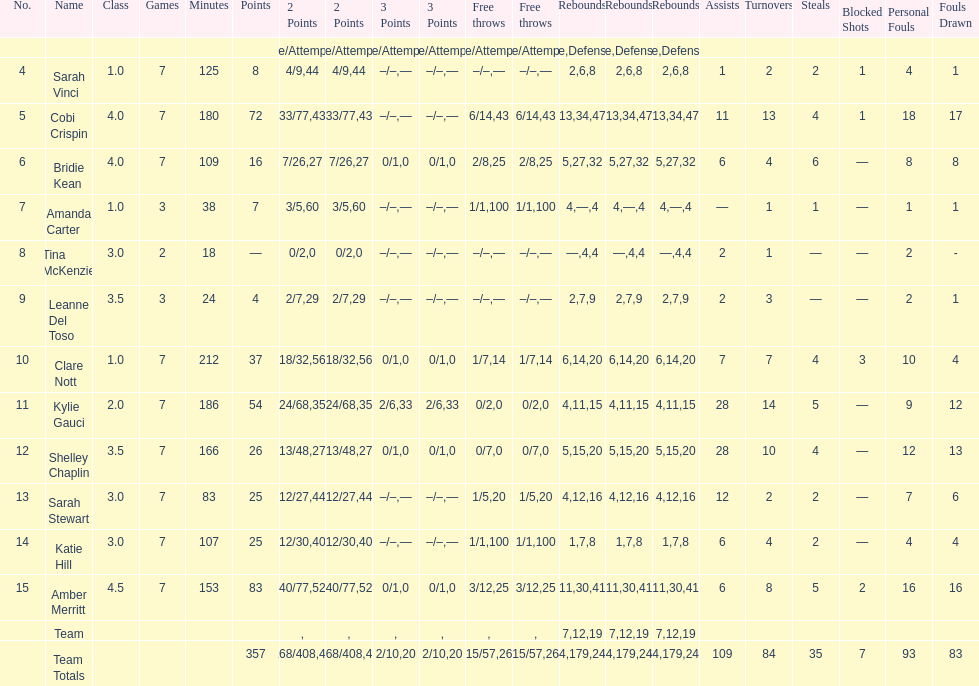Number of 3 points attempted 10. 